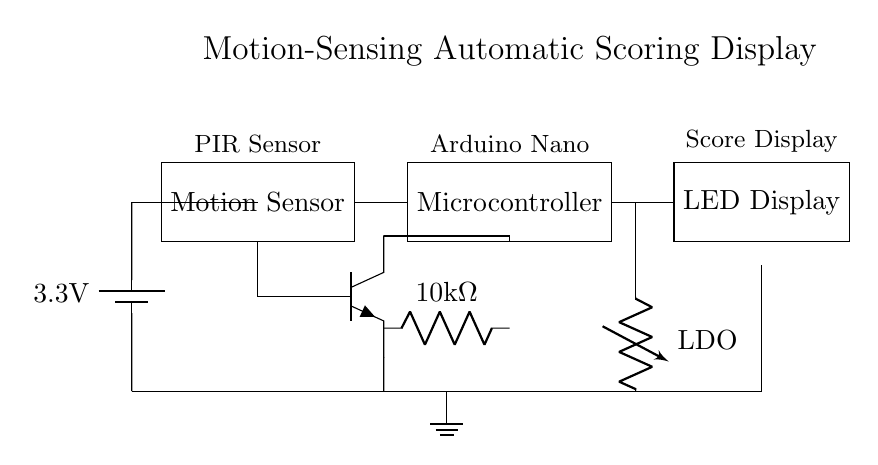What type of motion sensor is used in the circuit? The diagram labels the motion sensor as a "PIR Sensor," which stands for Passive Infrared Sensor, commonly used for detecting motion.
Answer: PIR Sensor What is the power supply voltage of the circuit? The circuit diagram specifies a battery with a voltage of "3.3V" connected across the components.
Answer: 3.3V Which component processes the sensor input? The microcontroller, labeled as "Arduino Nano" in the diagram, is responsible for processing the inputs from the PIR sensor and managing the LED display accordingly.
Answer: Arduino Nano What is the value of the resistor in this circuit? The circuit shows a resistor with a value of "10k Ohm," connected in series with the transistor, which helps manage the current flowing to the microcontroller.
Answer: 10k Ohm How does the motion detection affect the LED display? The motion sensor detects movement, sending a signal to the microcontroller (Arduino Nano), which then drives the LED display to show scores, indicating its direct role in the scoring display mechanism.
Answer: It drives the LED display What role does the transistor play in the circuit? The transistor acts as a switch or amplifier, controlling the current flow from the motion sensor to the microcontroller, which can enhance the signal and manage higher loads, improving the overall operation efficiency of the system.
Answer: It controls current flow What type of regulation does the circuit use? The diagram shows an "LDO," which stands for Low Drop-Out regulator, used for providing stable voltage output for sensitive components while drawing minimal current.
Answer: LDO 